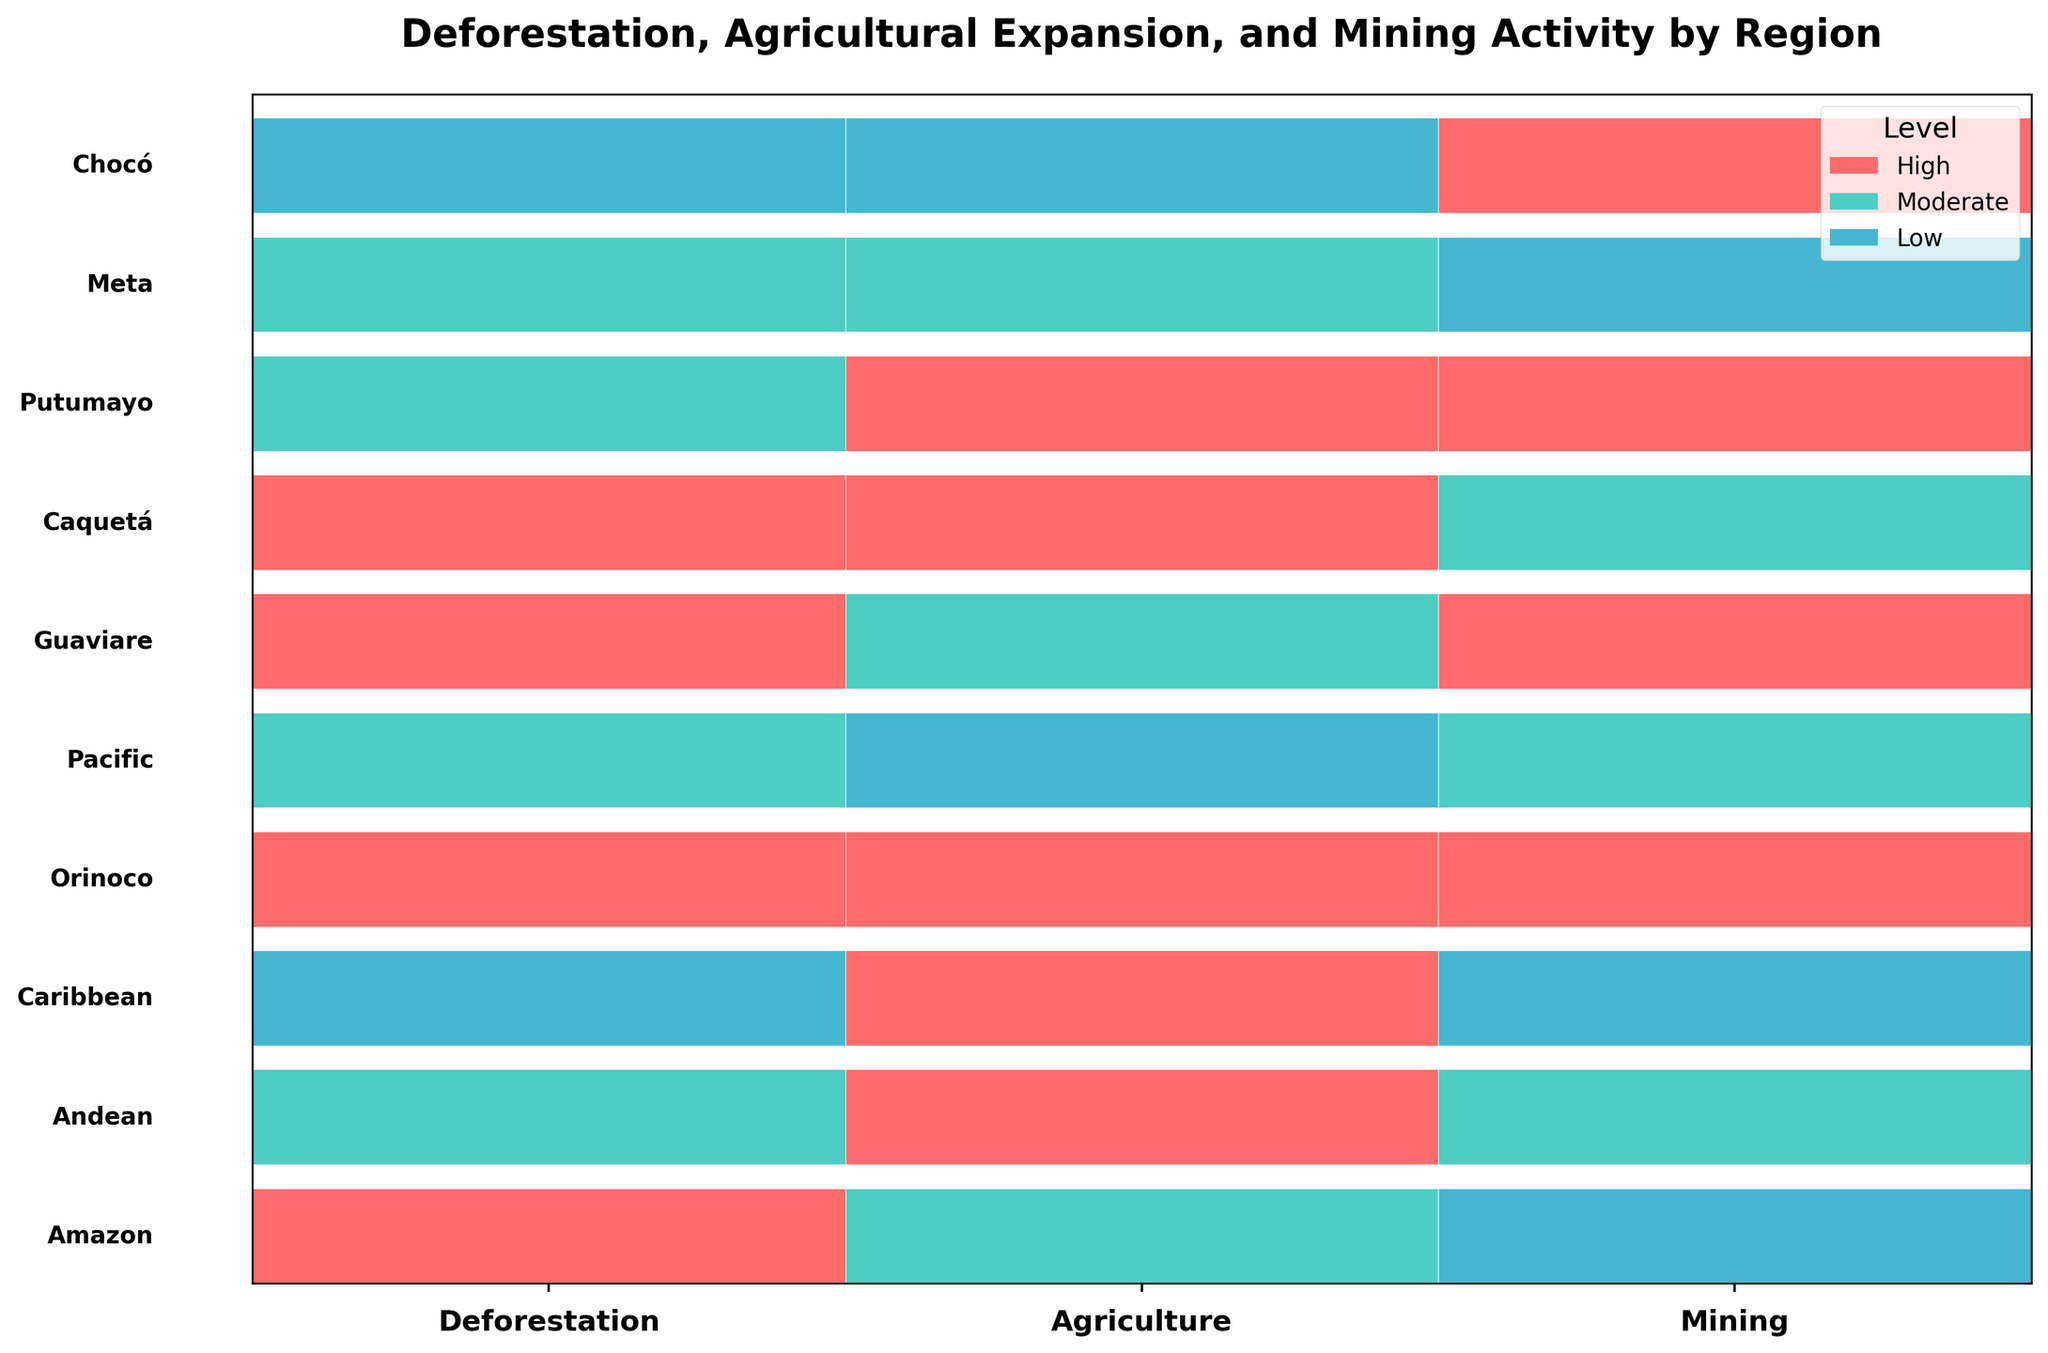How many regions have a high deforestation rate? Count the number of regions that are marked in the color representing high deforestation. According to the plot, these regions are Amazon, Orinoco, Guaviare, and Caquetá.
Answer: 4 Which region has high levels for all three activities (deforestation, agricultural expansion, and mining)? Identify a region that is marked with the color representing high in all three sections of the mosaic plot. The Orinoco region fits this criterion.
Answer: Orinoco What is the predominant agricultural activity level in the Andean region? Look at the Andean section of the plot, specifically in the agriculture part, which is the middle column. The color represents high agricultural expansion.
Answer: High How many regions exhibit moderate mining activity? Count the number of regions marked with the color representing moderate mining activity. There are Amazon, Andean, Pacific, and Caquetá regions.
Answer: 4 Compare the deforestation rates of Meta and Putumayo, which has a higher level? Observe the deforestation section (first column) for both Meta and Putumayo regions. Meta is moderate while Putumayo is also moderate, so they are equal.
Answer: Equal Which region has the lowest agricultural expansion level? Identify the region(s) marked with the color representing low agricultural expansion level. The Pacific and Chocó regions have low agricultural expansion levels.
Answer: Pacific, Chocó Are there more regions with high deforestation rates or moderate deforestation rates? Count the regions with high deforestation rates (4 regions: Amazon, Orinoco, Guaviare, Caquetá) and regions with moderate deforestation rates (3 regions: Andean, Pacific, Meta). There are more regions with high deforestation rates.
Answer: High How does the deforestation rate in the Amazon region compare to its mining activity level? Examine the Amazon part of the plot where the left column shows a high deforestation rate and the right column shows low mining activity.
Answer: Higher Which regions have both high agricultural expansion and high mining activity levels? Identify regions marked with high colors in both the agriculture (middle column) and mining (right column) sections. The regions that fit this criteria are Orinoco, Putumayo, and Caquetá.
Answer: Orinoco, Putumayo, Caquetá Does the Caribbean region have low, moderate, or high deforestation rate? Check the deforestation section of the Caribbean region in the plot. It shows the color representing low deforestation rate.
Answer: Low 